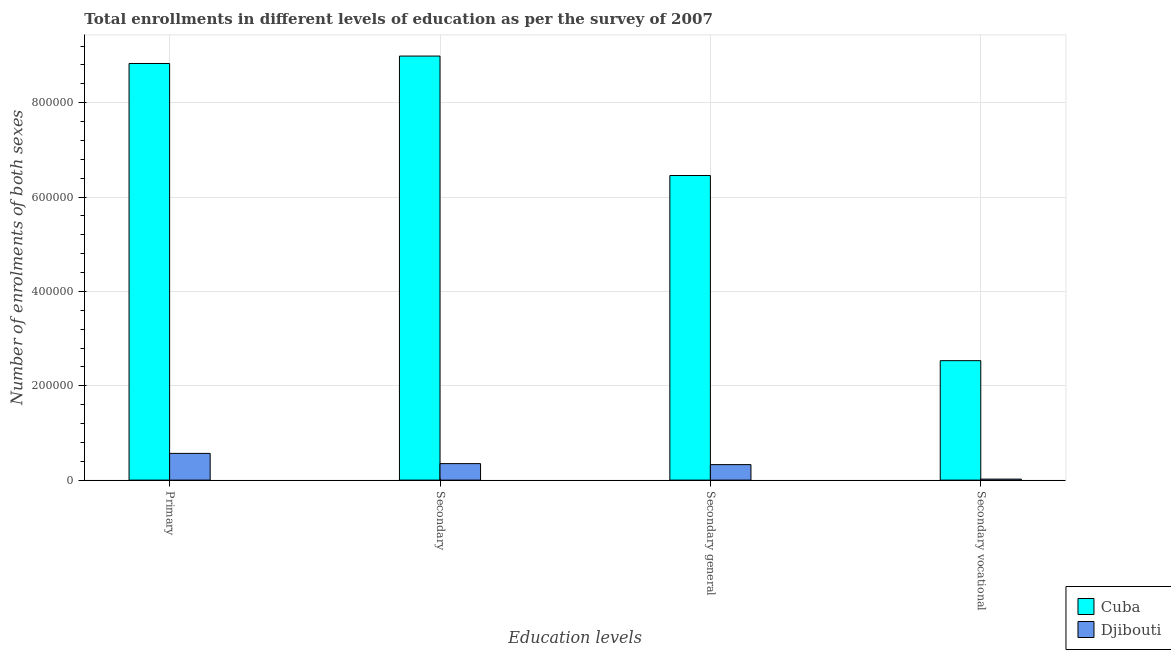How many different coloured bars are there?
Give a very brief answer. 2. Are the number of bars on each tick of the X-axis equal?
Offer a terse response. Yes. How many bars are there on the 3rd tick from the left?
Keep it short and to the point. 2. What is the label of the 1st group of bars from the left?
Your answer should be compact. Primary. What is the number of enrolments in secondary general education in Djibouti?
Offer a terse response. 3.29e+04. Across all countries, what is the maximum number of enrolments in secondary vocational education?
Keep it short and to the point. 2.53e+05. Across all countries, what is the minimum number of enrolments in primary education?
Give a very brief answer. 5.67e+04. In which country was the number of enrolments in primary education maximum?
Ensure brevity in your answer.  Cuba. In which country was the number of enrolments in secondary general education minimum?
Give a very brief answer. Djibouti. What is the total number of enrolments in secondary vocational education in the graph?
Your response must be concise. 2.55e+05. What is the difference between the number of enrolments in secondary general education in Djibouti and that in Cuba?
Keep it short and to the point. -6.13e+05. What is the difference between the number of enrolments in secondary vocational education in Cuba and the number of enrolments in secondary general education in Djibouti?
Ensure brevity in your answer.  2.20e+05. What is the average number of enrolments in secondary vocational education per country?
Your response must be concise. 1.28e+05. What is the difference between the number of enrolments in secondary vocational education and number of enrolments in secondary general education in Cuba?
Provide a short and direct response. -3.92e+05. What is the ratio of the number of enrolments in secondary education in Djibouti to that in Cuba?
Ensure brevity in your answer.  0.04. What is the difference between the highest and the second highest number of enrolments in secondary education?
Provide a short and direct response. 8.64e+05. What is the difference between the highest and the lowest number of enrolments in secondary vocational education?
Your answer should be compact. 2.51e+05. Is it the case that in every country, the sum of the number of enrolments in secondary general education and number of enrolments in secondary education is greater than the sum of number of enrolments in primary education and number of enrolments in secondary vocational education?
Make the answer very short. No. What does the 1st bar from the left in Secondary vocational represents?
Ensure brevity in your answer.  Cuba. What does the 2nd bar from the right in Secondary represents?
Keep it short and to the point. Cuba. Is it the case that in every country, the sum of the number of enrolments in primary education and number of enrolments in secondary education is greater than the number of enrolments in secondary general education?
Provide a short and direct response. Yes. Are all the bars in the graph horizontal?
Keep it short and to the point. No. How many countries are there in the graph?
Provide a short and direct response. 2. What is the difference between two consecutive major ticks on the Y-axis?
Provide a succinct answer. 2.00e+05. Are the values on the major ticks of Y-axis written in scientific E-notation?
Offer a terse response. No. Does the graph contain any zero values?
Provide a succinct answer. No. Does the graph contain grids?
Ensure brevity in your answer.  Yes. How many legend labels are there?
Your answer should be compact. 2. What is the title of the graph?
Provide a succinct answer. Total enrollments in different levels of education as per the survey of 2007. What is the label or title of the X-axis?
Give a very brief answer. Education levels. What is the label or title of the Y-axis?
Offer a terse response. Number of enrolments of both sexes. What is the Number of enrolments of both sexes in Cuba in Primary?
Make the answer very short. 8.83e+05. What is the Number of enrolments of both sexes of Djibouti in Primary?
Make the answer very short. 5.67e+04. What is the Number of enrolments of both sexes of Cuba in Secondary?
Offer a very short reply. 8.99e+05. What is the Number of enrolments of both sexes of Djibouti in Secondary?
Give a very brief answer. 3.50e+04. What is the Number of enrolments of both sexes of Cuba in Secondary general?
Your answer should be very brief. 6.46e+05. What is the Number of enrolments of both sexes of Djibouti in Secondary general?
Provide a short and direct response. 3.29e+04. What is the Number of enrolments of both sexes in Cuba in Secondary vocational?
Your response must be concise. 2.53e+05. What is the Number of enrolments of both sexes of Djibouti in Secondary vocational?
Your answer should be compact. 2108. Across all Education levels, what is the maximum Number of enrolments of both sexes of Cuba?
Offer a terse response. 8.99e+05. Across all Education levels, what is the maximum Number of enrolments of both sexes in Djibouti?
Keep it short and to the point. 5.67e+04. Across all Education levels, what is the minimum Number of enrolments of both sexes in Cuba?
Ensure brevity in your answer.  2.53e+05. Across all Education levels, what is the minimum Number of enrolments of both sexes in Djibouti?
Offer a terse response. 2108. What is the total Number of enrolments of both sexes of Cuba in the graph?
Provide a short and direct response. 2.68e+06. What is the total Number of enrolments of both sexes in Djibouti in the graph?
Your response must be concise. 1.27e+05. What is the difference between the Number of enrolments of both sexes of Cuba in Primary and that in Secondary?
Offer a very short reply. -1.57e+04. What is the difference between the Number of enrolments of both sexes of Djibouti in Primary and that in Secondary?
Your answer should be compact. 2.17e+04. What is the difference between the Number of enrolments of both sexes of Cuba in Primary and that in Secondary general?
Provide a short and direct response. 2.37e+05. What is the difference between the Number of enrolments of both sexes in Djibouti in Primary and that in Secondary general?
Your response must be concise. 2.38e+04. What is the difference between the Number of enrolments of both sexes of Cuba in Primary and that in Secondary vocational?
Offer a terse response. 6.30e+05. What is the difference between the Number of enrolments of both sexes in Djibouti in Primary and that in Secondary vocational?
Provide a succinct answer. 5.46e+04. What is the difference between the Number of enrolments of both sexes in Cuba in Secondary and that in Secondary general?
Make the answer very short. 2.53e+05. What is the difference between the Number of enrolments of both sexes of Djibouti in Secondary and that in Secondary general?
Your answer should be compact. 2108. What is the difference between the Number of enrolments of both sexes in Cuba in Secondary and that in Secondary vocational?
Offer a terse response. 6.46e+05. What is the difference between the Number of enrolments of both sexes of Djibouti in Secondary and that in Secondary vocational?
Your answer should be very brief. 3.29e+04. What is the difference between the Number of enrolments of both sexes in Cuba in Secondary general and that in Secondary vocational?
Ensure brevity in your answer.  3.92e+05. What is the difference between the Number of enrolments of both sexes of Djibouti in Secondary general and that in Secondary vocational?
Make the answer very short. 3.08e+04. What is the difference between the Number of enrolments of both sexes in Cuba in Primary and the Number of enrolments of both sexes in Djibouti in Secondary?
Your answer should be very brief. 8.48e+05. What is the difference between the Number of enrolments of both sexes of Cuba in Primary and the Number of enrolments of both sexes of Djibouti in Secondary general?
Your answer should be very brief. 8.50e+05. What is the difference between the Number of enrolments of both sexes in Cuba in Primary and the Number of enrolments of both sexes in Djibouti in Secondary vocational?
Your answer should be compact. 8.81e+05. What is the difference between the Number of enrolments of both sexes in Cuba in Secondary and the Number of enrolments of both sexes in Djibouti in Secondary general?
Your answer should be very brief. 8.66e+05. What is the difference between the Number of enrolments of both sexes of Cuba in Secondary and the Number of enrolments of both sexes of Djibouti in Secondary vocational?
Your response must be concise. 8.97e+05. What is the difference between the Number of enrolments of both sexes of Cuba in Secondary general and the Number of enrolments of both sexes of Djibouti in Secondary vocational?
Provide a succinct answer. 6.44e+05. What is the average Number of enrolments of both sexes in Cuba per Education levels?
Your answer should be compact. 6.70e+05. What is the average Number of enrolments of both sexes of Djibouti per Education levels?
Ensure brevity in your answer.  3.17e+04. What is the difference between the Number of enrolments of both sexes in Cuba and Number of enrolments of both sexes in Djibouti in Primary?
Your answer should be compact. 8.26e+05. What is the difference between the Number of enrolments of both sexes of Cuba and Number of enrolments of both sexes of Djibouti in Secondary?
Your answer should be compact. 8.64e+05. What is the difference between the Number of enrolments of both sexes of Cuba and Number of enrolments of both sexes of Djibouti in Secondary general?
Keep it short and to the point. 6.13e+05. What is the difference between the Number of enrolments of both sexes in Cuba and Number of enrolments of both sexes in Djibouti in Secondary vocational?
Offer a terse response. 2.51e+05. What is the ratio of the Number of enrolments of both sexes of Cuba in Primary to that in Secondary?
Your answer should be very brief. 0.98. What is the ratio of the Number of enrolments of both sexes of Djibouti in Primary to that in Secondary?
Provide a succinct answer. 1.62. What is the ratio of the Number of enrolments of both sexes of Cuba in Primary to that in Secondary general?
Provide a succinct answer. 1.37. What is the ratio of the Number of enrolments of both sexes of Djibouti in Primary to that in Secondary general?
Offer a terse response. 1.72. What is the ratio of the Number of enrolments of both sexes in Cuba in Primary to that in Secondary vocational?
Your answer should be very brief. 3.49. What is the ratio of the Number of enrolments of both sexes in Djibouti in Primary to that in Secondary vocational?
Ensure brevity in your answer.  26.88. What is the ratio of the Number of enrolments of both sexes in Cuba in Secondary to that in Secondary general?
Offer a terse response. 1.39. What is the ratio of the Number of enrolments of both sexes of Djibouti in Secondary to that in Secondary general?
Your answer should be very brief. 1.06. What is the ratio of the Number of enrolments of both sexes of Cuba in Secondary to that in Secondary vocational?
Make the answer very short. 3.55. What is the ratio of the Number of enrolments of both sexes in Djibouti in Secondary to that in Secondary vocational?
Your response must be concise. 16.59. What is the ratio of the Number of enrolments of both sexes in Cuba in Secondary general to that in Secondary vocational?
Offer a very short reply. 2.55. What is the ratio of the Number of enrolments of both sexes in Djibouti in Secondary general to that in Secondary vocational?
Your answer should be very brief. 15.59. What is the difference between the highest and the second highest Number of enrolments of both sexes in Cuba?
Provide a short and direct response. 1.57e+04. What is the difference between the highest and the second highest Number of enrolments of both sexes in Djibouti?
Offer a very short reply. 2.17e+04. What is the difference between the highest and the lowest Number of enrolments of both sexes of Cuba?
Give a very brief answer. 6.46e+05. What is the difference between the highest and the lowest Number of enrolments of both sexes of Djibouti?
Your response must be concise. 5.46e+04. 